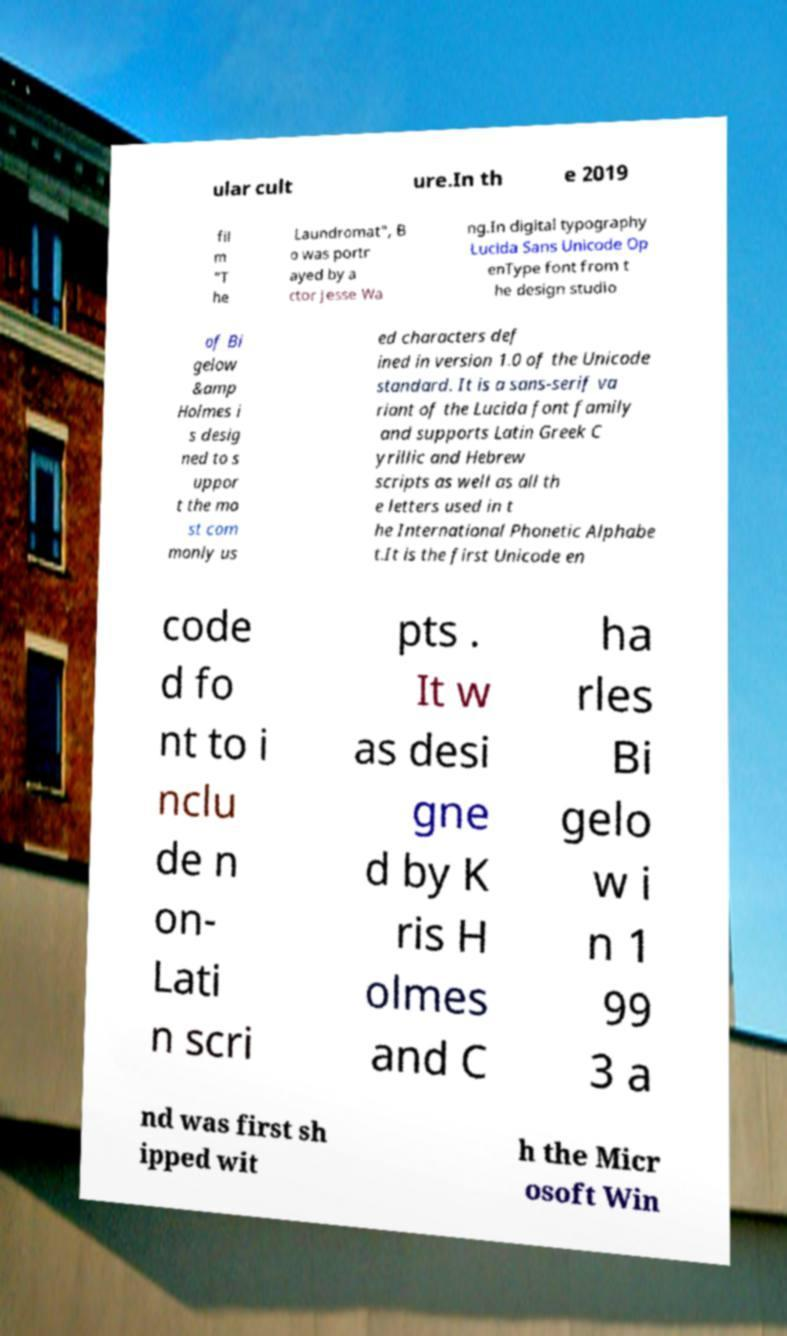Please read and relay the text visible in this image. What does it say? ular cult ure.In th e 2019 fil m "T he Laundromat", B o was portr ayed by a ctor Jesse Wa ng.In digital typography Lucida Sans Unicode Op enType font from t he design studio of Bi gelow &amp Holmes i s desig ned to s uppor t the mo st com monly us ed characters def ined in version 1.0 of the Unicode standard. It is a sans-serif va riant of the Lucida font family and supports Latin Greek C yrillic and Hebrew scripts as well as all th e letters used in t he International Phonetic Alphabe t.It is the first Unicode en code d fo nt to i nclu de n on- Lati n scri pts . It w as desi gne d by K ris H olmes and C ha rles Bi gelo w i n 1 99 3 a nd was first sh ipped wit h the Micr osoft Win 